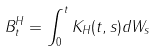<formula> <loc_0><loc_0><loc_500><loc_500>B ^ { H } _ { t } = \int _ { 0 } ^ { t } K _ { H } ( t , s ) d W _ { s }</formula> 